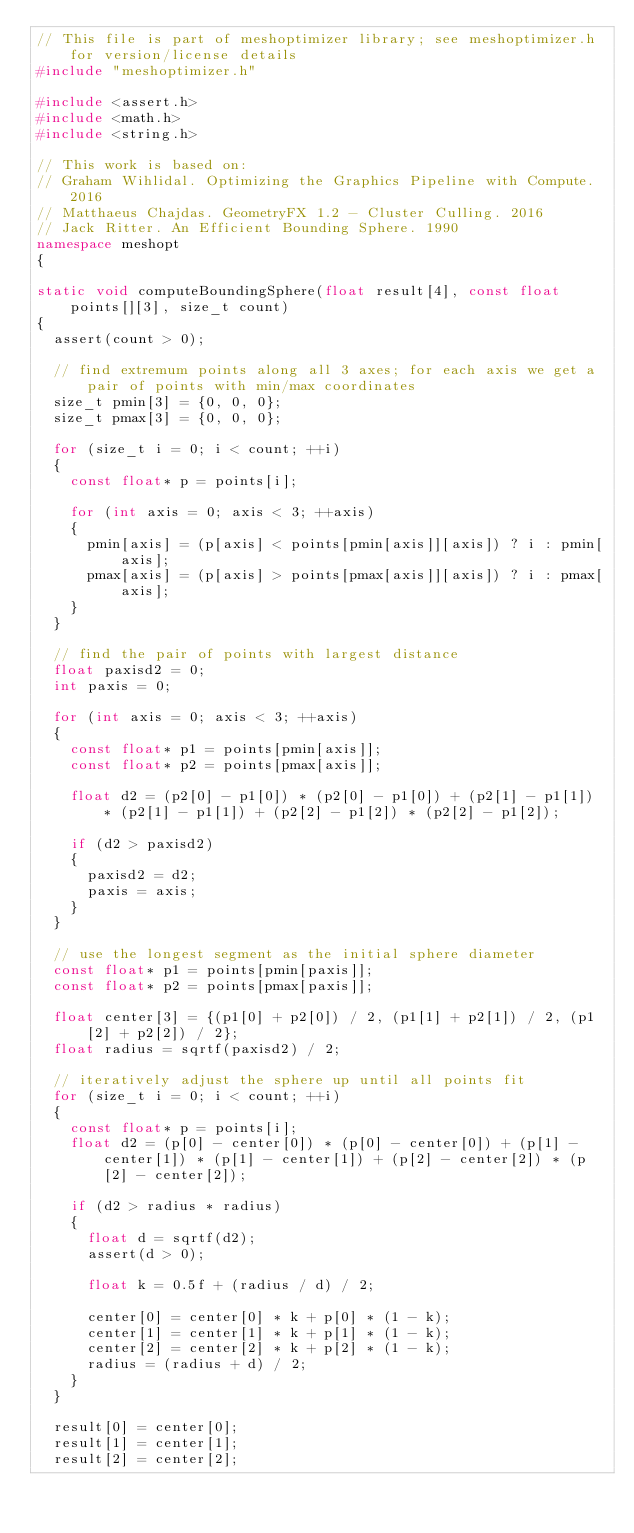Convert code to text. <code><loc_0><loc_0><loc_500><loc_500><_C++_>// This file is part of meshoptimizer library; see meshoptimizer.h for version/license details
#include "meshoptimizer.h"

#include <assert.h>
#include <math.h>
#include <string.h>

// This work is based on:
// Graham Wihlidal. Optimizing the Graphics Pipeline with Compute. 2016
// Matthaeus Chajdas. GeometryFX 1.2 - Cluster Culling. 2016
// Jack Ritter. An Efficient Bounding Sphere. 1990
namespace meshopt
{

static void computeBoundingSphere(float result[4], const float points[][3], size_t count)
{
	assert(count > 0);

	// find extremum points along all 3 axes; for each axis we get a pair of points with min/max coordinates
	size_t pmin[3] = {0, 0, 0};
	size_t pmax[3] = {0, 0, 0};

	for (size_t i = 0; i < count; ++i)
	{
		const float* p = points[i];

		for (int axis = 0; axis < 3; ++axis)
		{
			pmin[axis] = (p[axis] < points[pmin[axis]][axis]) ? i : pmin[axis];
			pmax[axis] = (p[axis] > points[pmax[axis]][axis]) ? i : pmax[axis];
		}
	}

	// find the pair of points with largest distance
	float paxisd2 = 0;
	int paxis = 0;

	for (int axis = 0; axis < 3; ++axis)
	{
		const float* p1 = points[pmin[axis]];
		const float* p2 = points[pmax[axis]];

		float d2 = (p2[0] - p1[0]) * (p2[0] - p1[0]) + (p2[1] - p1[1]) * (p2[1] - p1[1]) + (p2[2] - p1[2]) * (p2[2] - p1[2]);

		if (d2 > paxisd2)
		{
			paxisd2 = d2;
			paxis = axis;
		}
	}

	// use the longest segment as the initial sphere diameter
	const float* p1 = points[pmin[paxis]];
	const float* p2 = points[pmax[paxis]];

	float center[3] = {(p1[0] + p2[0]) / 2, (p1[1] + p2[1]) / 2, (p1[2] + p2[2]) / 2};
	float radius = sqrtf(paxisd2) / 2;

	// iteratively adjust the sphere up until all points fit
	for (size_t i = 0; i < count; ++i)
	{
		const float* p = points[i];
		float d2 = (p[0] - center[0]) * (p[0] - center[0]) + (p[1] - center[1]) * (p[1] - center[1]) + (p[2] - center[2]) * (p[2] - center[2]);

		if (d2 > radius * radius)
		{
			float d = sqrtf(d2);
			assert(d > 0);

			float k = 0.5f + (radius / d) / 2;

			center[0] = center[0] * k + p[0] * (1 - k);
			center[1] = center[1] * k + p[1] * (1 - k);
			center[2] = center[2] * k + p[2] * (1 - k);
			radius = (radius + d) / 2;
		}
	}

	result[0] = center[0];
	result[1] = center[1];
	result[2] = center[2];</code> 